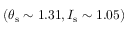Convert formula to latex. <formula><loc_0><loc_0><loc_500><loc_500>( \theta _ { s } \sim 1 . 3 1 , I _ { s } \sim 1 . 0 5 )</formula> 